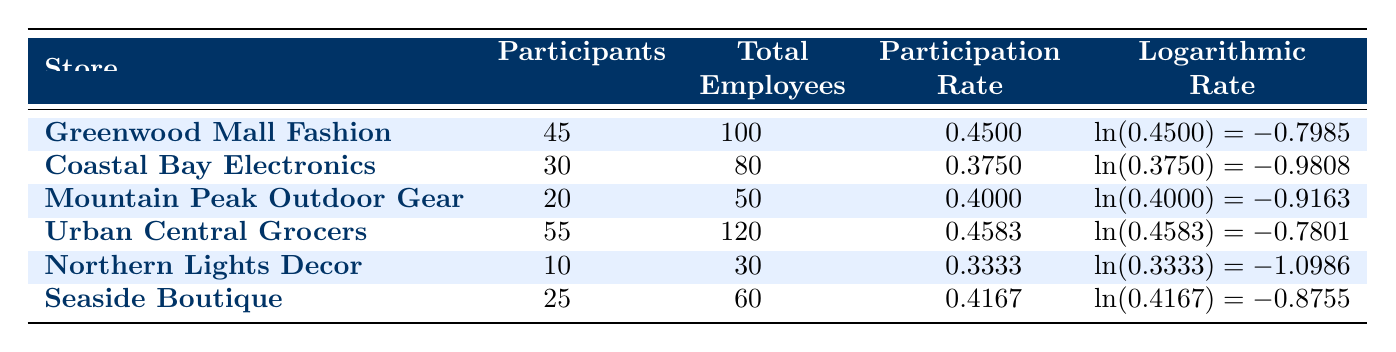What is the participation rate for Seaside Boutique? The table shows that the participation rate for Seaside Boutique is listed in the column for participation rate next to its store name. According to the table, it is 0.4167.
Answer: 0.4167 Which store has the highest number of participants? By comparing the values in the participants column, Urban Central Grocers has the highest number at 55 participants.
Answer: Urban Central Grocers Is the participation rate for Coastal Bay Electronics above 0.4? The table shows that the participation rate for Coastal Bay Electronics is 0.375, which is below 0.4. Therefore, the answer is no.
Answer: No What is the average participation rate of all stores listed? To find the average, add together all the participation rates: (0.45 + 0.375 + 0.4 + 0.4583 + 0.3333 + 0.4167) = 2.4333. There are 6 stores, so the average is 2.4333/6 = 0.4056.
Answer: 0.4056 Which store has the lowest participation rate, and what is it? By examining the participation rates in the table, Northern Lights Decor has the lowest participation rate at 0.3333.
Answer: Northern Lights Decor, 0.3333 What is the difference in participation rates between Urban Central Grocers and Northern Lights Decor? Urban Central Grocers has a participation rate of 0.4583, and Northern Lights Decor has a rate of 0.3333. The difference is calculated as 0.4583 - 0.3333 = 0.1250.
Answer: 0.1250 Are more than half of the stores listed achieving a participation rate above 0.4? The stores with participation rates above 0.4 are Greenwood Mall Fashion (0.4500), Mountain Peak Outdoor Gear (0.4000), Urban Central Grocers (0.4583), and Seaside Boutique (0.4167). That totals 4 out of 6 stores, which is more than half, thus the answer is yes.
Answer: Yes What is the total number of participants across all stores? To find the total number of participants, add the participants of each store: (45 + 30 + 20 + 55 + 10 + 25) = 185.
Answer: 185 